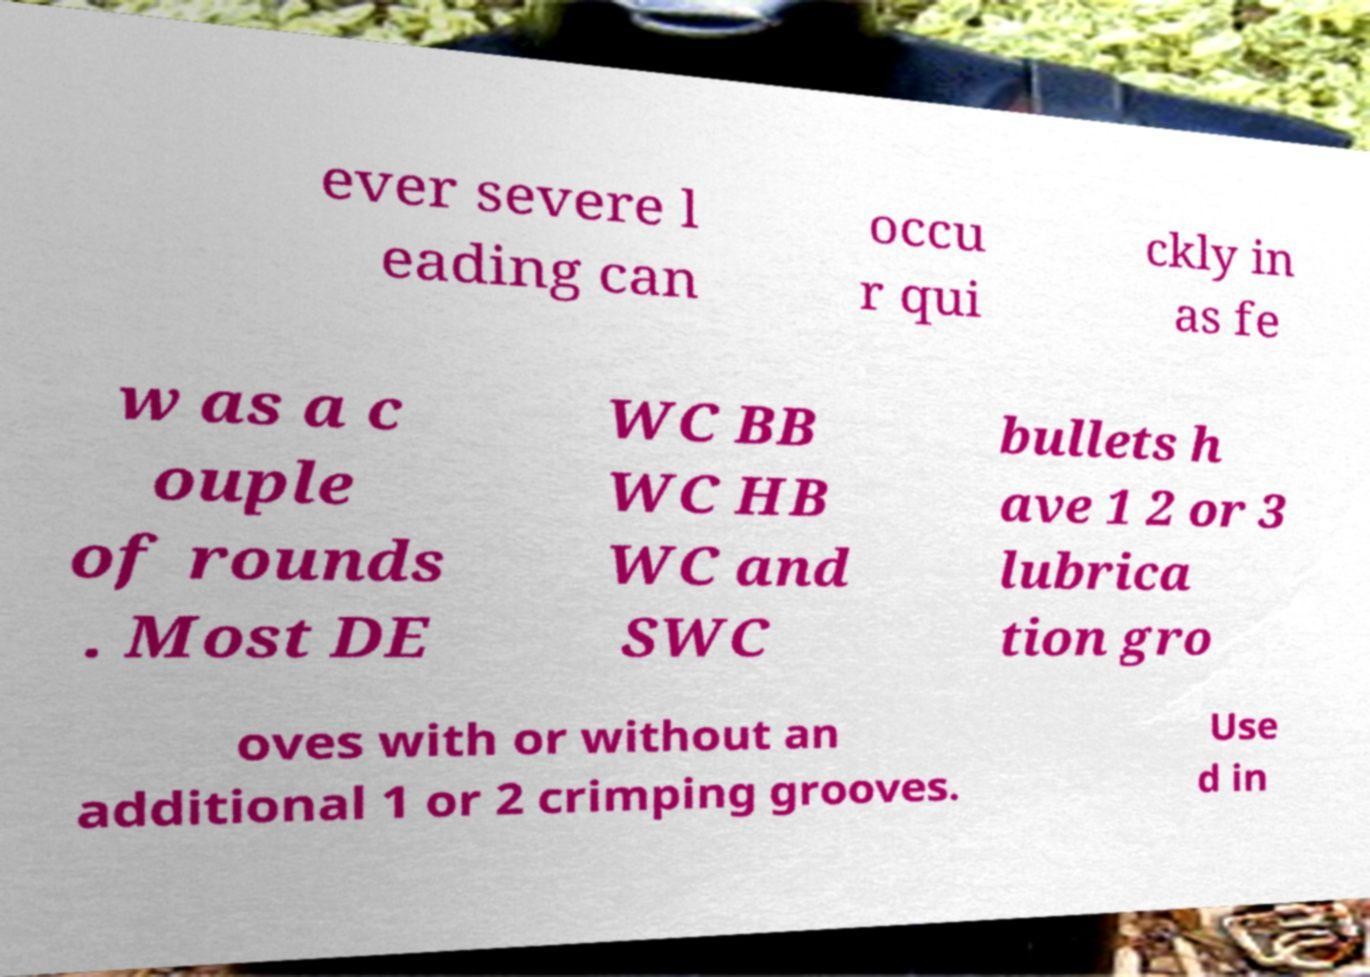Can you read and provide the text displayed in the image?This photo seems to have some interesting text. Can you extract and type it out for me? ever severe l eading can occu r qui ckly in as fe w as a c ouple of rounds . Most DE WC BB WC HB WC and SWC bullets h ave 1 2 or 3 lubrica tion gro oves with or without an additional 1 or 2 crimping grooves. Use d in 